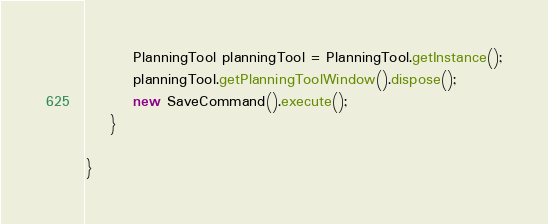Convert code to text. <code><loc_0><loc_0><loc_500><loc_500><_Java_>		PlanningTool planningTool = PlanningTool.getInstance();
		planningTool.getPlanningToolWindow().dispose();
		new SaveCommand().execute();
	}

}
</code> 